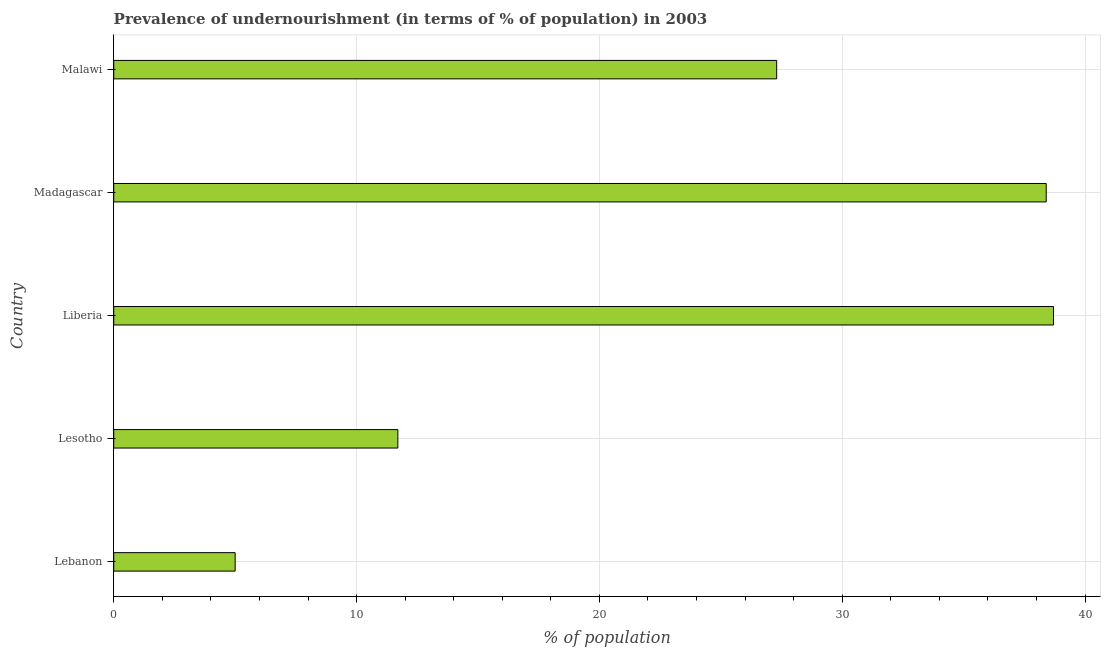Does the graph contain grids?
Your answer should be very brief. Yes. What is the title of the graph?
Give a very brief answer. Prevalence of undernourishment (in terms of % of population) in 2003. What is the label or title of the X-axis?
Your answer should be very brief. % of population. What is the percentage of undernourished population in Malawi?
Your answer should be very brief. 27.3. Across all countries, what is the maximum percentage of undernourished population?
Your response must be concise. 38.7. In which country was the percentage of undernourished population maximum?
Give a very brief answer. Liberia. In which country was the percentage of undernourished population minimum?
Offer a terse response. Lebanon. What is the sum of the percentage of undernourished population?
Your answer should be compact. 121.1. What is the difference between the percentage of undernourished population in Liberia and Malawi?
Make the answer very short. 11.4. What is the average percentage of undernourished population per country?
Offer a very short reply. 24.22. What is the median percentage of undernourished population?
Offer a very short reply. 27.3. In how many countries, is the percentage of undernourished population greater than 14 %?
Your answer should be compact. 3. Is the percentage of undernourished population in Lebanon less than that in Madagascar?
Your answer should be very brief. Yes. Is the difference between the percentage of undernourished population in Liberia and Malawi greater than the difference between any two countries?
Your response must be concise. No. Is the sum of the percentage of undernourished population in Lesotho and Malawi greater than the maximum percentage of undernourished population across all countries?
Ensure brevity in your answer.  Yes. What is the difference between the highest and the lowest percentage of undernourished population?
Give a very brief answer. 33.7. How many bars are there?
Your answer should be very brief. 5. How many countries are there in the graph?
Ensure brevity in your answer.  5. Are the values on the major ticks of X-axis written in scientific E-notation?
Offer a terse response. No. What is the % of population in Lebanon?
Your response must be concise. 5. What is the % of population in Lesotho?
Your answer should be compact. 11.7. What is the % of population in Liberia?
Keep it short and to the point. 38.7. What is the % of population of Madagascar?
Provide a short and direct response. 38.4. What is the % of population in Malawi?
Offer a very short reply. 27.3. What is the difference between the % of population in Lebanon and Liberia?
Provide a succinct answer. -33.7. What is the difference between the % of population in Lebanon and Madagascar?
Provide a short and direct response. -33.4. What is the difference between the % of population in Lebanon and Malawi?
Ensure brevity in your answer.  -22.3. What is the difference between the % of population in Lesotho and Madagascar?
Your answer should be very brief. -26.7. What is the difference between the % of population in Lesotho and Malawi?
Ensure brevity in your answer.  -15.6. What is the difference between the % of population in Liberia and Madagascar?
Give a very brief answer. 0.3. What is the difference between the % of population in Liberia and Malawi?
Your answer should be very brief. 11.4. What is the ratio of the % of population in Lebanon to that in Lesotho?
Your answer should be compact. 0.43. What is the ratio of the % of population in Lebanon to that in Liberia?
Provide a succinct answer. 0.13. What is the ratio of the % of population in Lebanon to that in Madagascar?
Give a very brief answer. 0.13. What is the ratio of the % of population in Lebanon to that in Malawi?
Make the answer very short. 0.18. What is the ratio of the % of population in Lesotho to that in Liberia?
Your answer should be compact. 0.3. What is the ratio of the % of population in Lesotho to that in Madagascar?
Give a very brief answer. 0.3. What is the ratio of the % of population in Lesotho to that in Malawi?
Provide a succinct answer. 0.43. What is the ratio of the % of population in Liberia to that in Madagascar?
Provide a short and direct response. 1.01. What is the ratio of the % of population in Liberia to that in Malawi?
Give a very brief answer. 1.42. What is the ratio of the % of population in Madagascar to that in Malawi?
Provide a short and direct response. 1.41. 